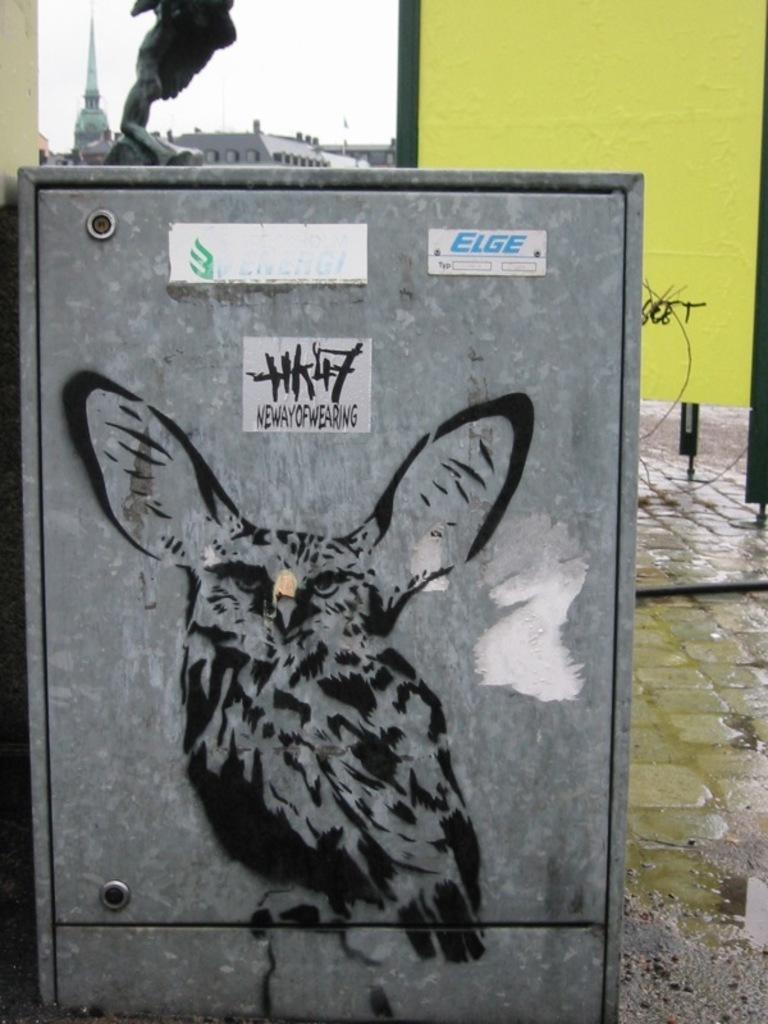What is the main object in the image? There is a metal box in the image. What is depicted on the metal box? The metal box has a painting of a bird on it. Are there any other decorations on the metal box? Yes, there are posters on the metal box. What can be seen in the background of the image? The ground, a wall, and other objects are visible in the background of the image. What type of honey is being collected by the fowl in the image? There is no fowl or honey present in the image; it features a metal box with a bird painting and posters. What is the fowl writing on the metal box in the image? There is no fowl or writing present on the metal box in the image; it only has a bird painting and posters. 